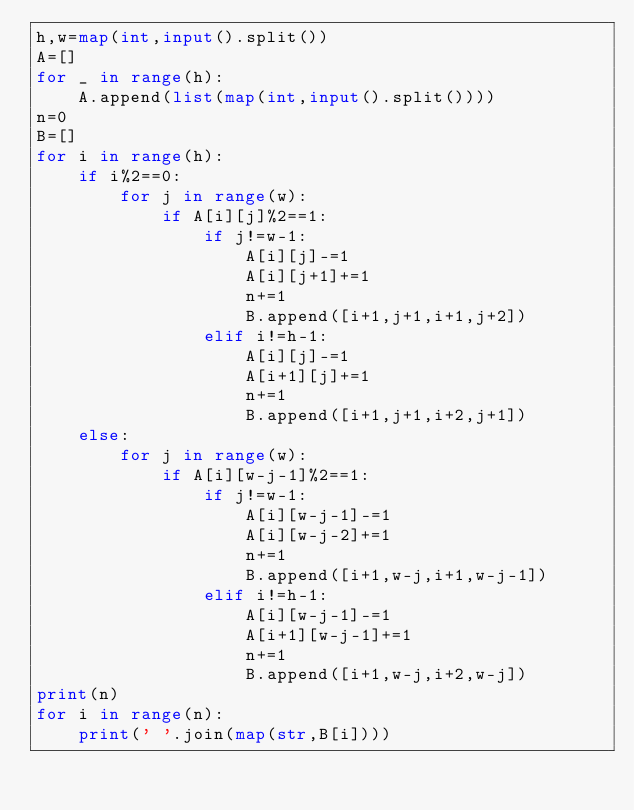Convert code to text. <code><loc_0><loc_0><loc_500><loc_500><_Python_>h,w=map(int,input().split())
A=[]
for _ in range(h):
    A.append(list(map(int,input().split())))
n=0
B=[]
for i in range(h):
    if i%2==0:
        for j in range(w):
            if A[i][j]%2==1:
                if j!=w-1:
                    A[i][j]-=1
                    A[i][j+1]+=1
                    n+=1
                    B.append([i+1,j+1,i+1,j+2])
                elif i!=h-1:
                    A[i][j]-=1
                    A[i+1][j]+=1
                    n+=1
                    B.append([i+1,j+1,i+2,j+1])
    else:
        for j in range(w):
            if A[i][w-j-1]%2==1:
                if j!=w-1:
                    A[i][w-j-1]-=1
                    A[i][w-j-2]+=1
                    n+=1
                    B.append([i+1,w-j,i+1,w-j-1])
                elif i!=h-1:
                    A[i][w-j-1]-=1
                    A[i+1][w-j-1]+=1
                    n+=1
                    B.append([i+1,w-j,i+2,w-j])
print(n)
for i in range(n):
    print(' '.join(map(str,B[i])))</code> 